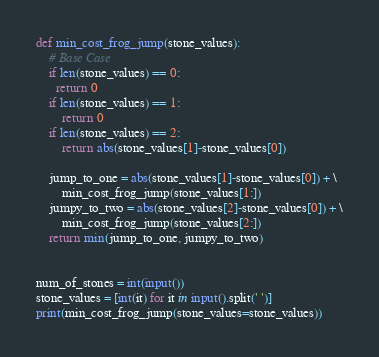<code> <loc_0><loc_0><loc_500><loc_500><_Python_>def min_cost_frog_jump(stone_values):
    # Base Case
    if len(stone_values) == 0:
      return 0
    if len(stone_values) == 1:
        return 0
    if len(stone_values) == 2:
        return abs(stone_values[1]-stone_values[0])

    jump_to_one = abs(stone_values[1]-stone_values[0]) + \
        min_cost_frog_jump(stone_values[1:])
    jumpy_to_two = abs(stone_values[2]-stone_values[0]) + \
        min_cost_frog_jump(stone_values[2:])
    return min(jump_to_one, jumpy_to_two)


num_of_stones = int(input())
stone_values = [int(it) for it in input().split(' ')]
print(min_cost_frog_jump(stone_values=stone_values))
</code> 